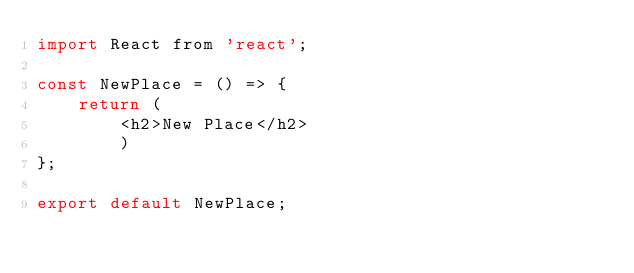<code> <loc_0><loc_0><loc_500><loc_500><_JavaScript_>import React from 'react';

const NewPlace = () => {
    return (
        <h2>New Place</h2>
        )
};

export default NewPlace;</code> 